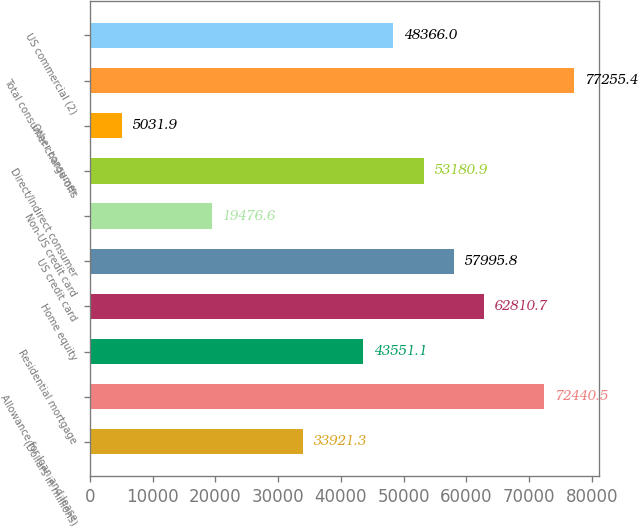Convert chart to OTSL. <chart><loc_0><loc_0><loc_500><loc_500><bar_chart><fcel>(Dollars in millions)<fcel>Allowance for loan and lease<fcel>Residential mortgage<fcel>Home equity<fcel>US credit card<fcel>Non-US credit card<fcel>Direct/Indirect consumer<fcel>Other consumer<fcel>Total consumer charge-offs<fcel>US commercial (2)<nl><fcel>33921.3<fcel>72440.5<fcel>43551.1<fcel>62810.7<fcel>57995.8<fcel>19476.6<fcel>53180.9<fcel>5031.9<fcel>77255.4<fcel>48366<nl></chart> 